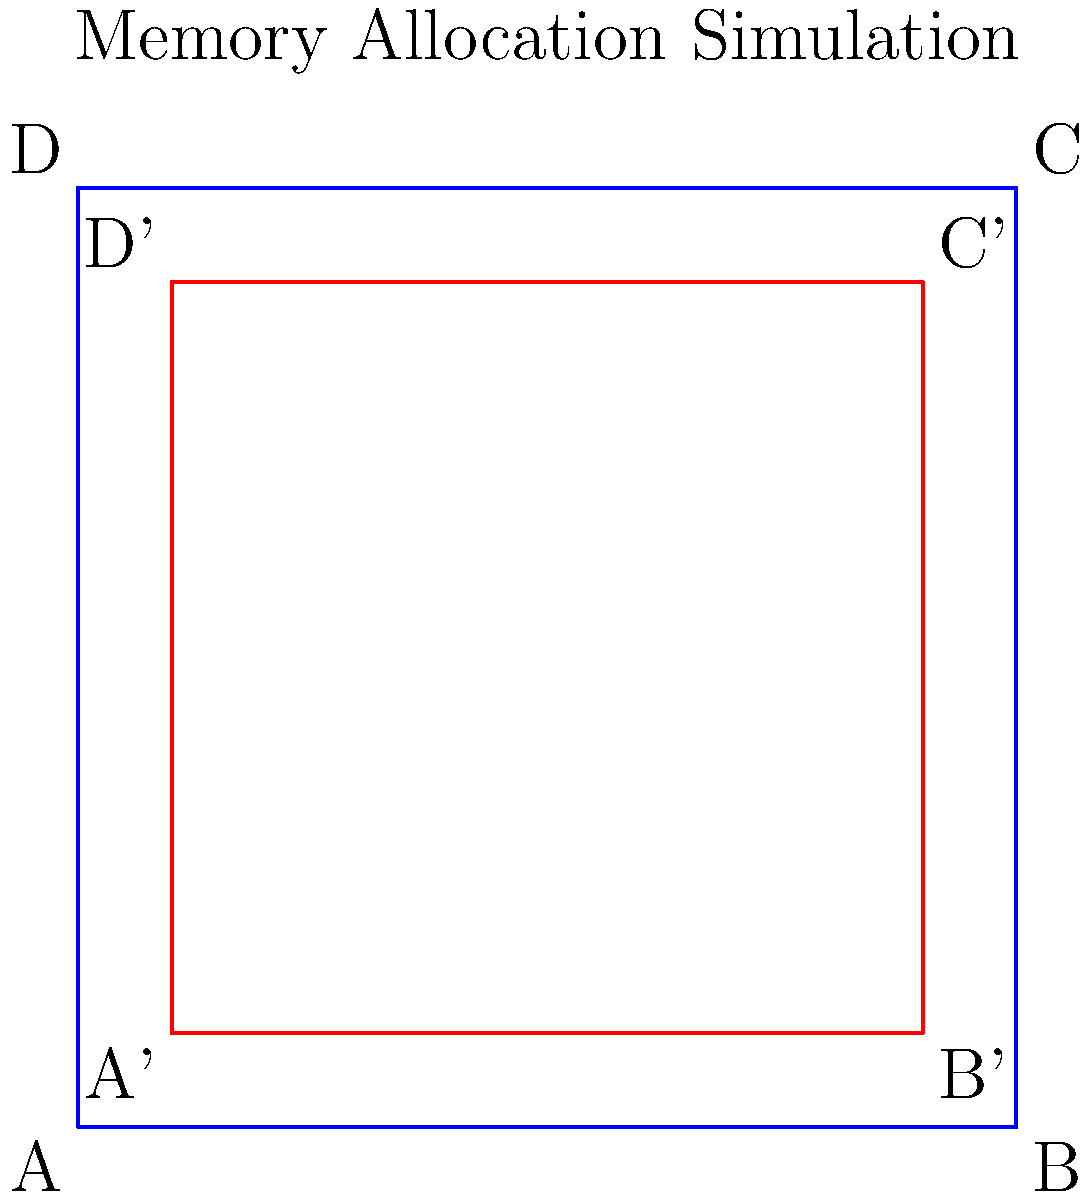In a Unix system, you need to implement a memory allocation algorithm that scales coordinates to fit within a bounded area. Given a rectangular memory block with original coordinates A(0,0), B(10,0), C(10,10), and D(0,10), you need to scale it to fit within a slightly smaller area while maintaining a 1-unit buffer on all sides. What is the scaling factor that should be applied to the original coordinates to achieve this? To solve this problem, we need to follow these steps:

1. Identify the original dimensions:
   - Width = 10 units
   - Height = 10 units

2. Determine the new dimensions with the 1-unit buffer:
   - New width = 10 - 2 = 8 units
   - New height = 10 - 2 = 8 units

3. Calculate the scaling factor:
   - Scaling factor = New dimension / Original dimension
   - For both width and height: 8 / 10 = 0.8

4. Verify the scaling:
   - Original coordinates: (0,0), (10,0), (10,10), (0,10)
   - Scaled coordinates before translation: (0,0), (8,0), (8,8), (0,8)
   - Add 1-unit buffer: (1,1), (9,1), (9,9), (1,9)

The scaling factor of 0.8 correctly scales the original 10x10 area to fit within the 8x8 area, which when translated by 1 unit in both x and y directions, fits within the original area with a 1-unit buffer on all sides.

This scaling approach is analogous to memory allocation in Unix systems, where you might need to allocate a slightly smaller block of memory within a larger available space, leaving some buffer for metadata or alignment purposes.
Answer: 0.8 